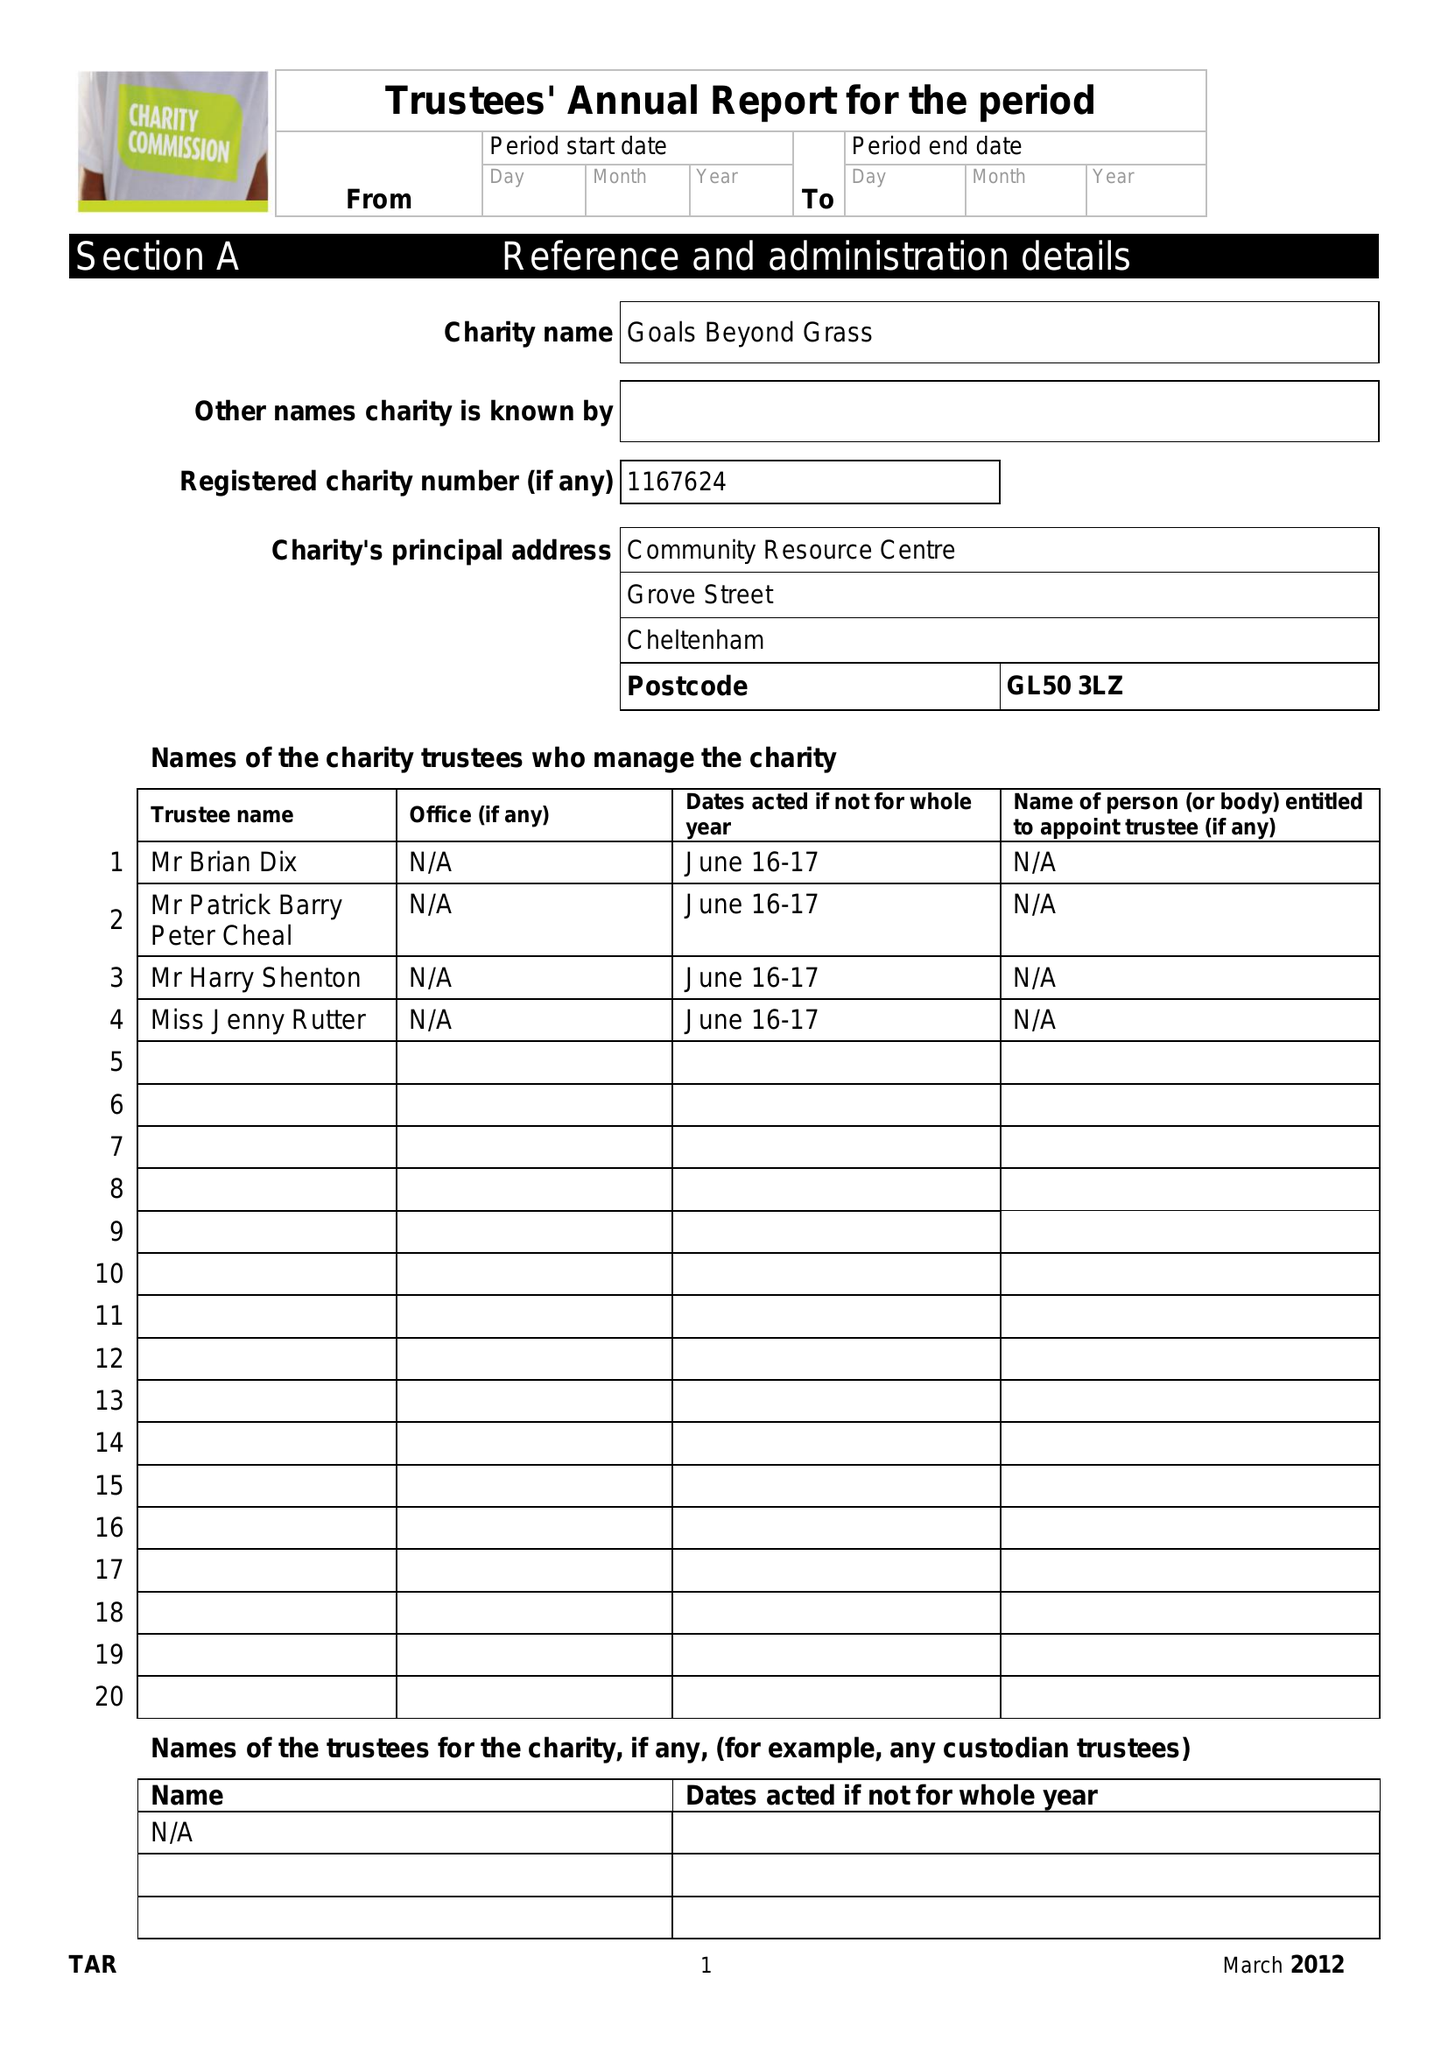What is the value for the income_annually_in_british_pounds?
Answer the question using a single word or phrase. 36090.00 